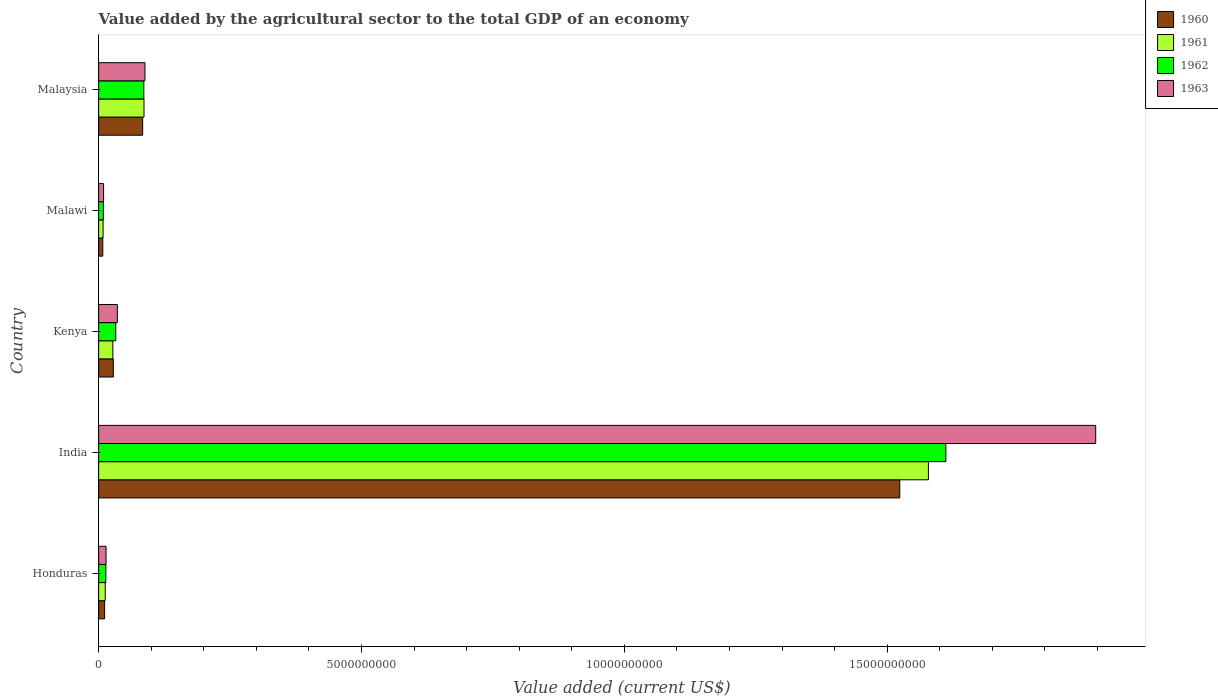How many different coloured bars are there?
Give a very brief answer. 4. How many groups of bars are there?
Your response must be concise. 5. Are the number of bars per tick equal to the number of legend labels?
Offer a terse response. Yes. Are the number of bars on each tick of the Y-axis equal?
Keep it short and to the point. Yes. How many bars are there on the 5th tick from the bottom?
Provide a short and direct response. 4. What is the label of the 4th group of bars from the top?
Your answer should be very brief. India. In how many cases, is the number of bars for a given country not equal to the number of legend labels?
Ensure brevity in your answer.  0. What is the value added by the agricultural sector to the total GDP in 1961 in Malaysia?
Your response must be concise. 8.63e+08. Across all countries, what is the maximum value added by the agricultural sector to the total GDP in 1962?
Your answer should be very brief. 1.61e+1. Across all countries, what is the minimum value added by the agricultural sector to the total GDP in 1960?
Keep it short and to the point. 7.88e+07. In which country was the value added by the agricultural sector to the total GDP in 1963 maximum?
Make the answer very short. India. In which country was the value added by the agricultural sector to the total GDP in 1960 minimum?
Make the answer very short. Malawi. What is the total value added by the agricultural sector to the total GDP in 1960 in the graph?
Give a very brief answer. 1.65e+1. What is the difference between the value added by the agricultural sector to the total GDP in 1961 in India and that in Malawi?
Provide a succinct answer. 1.57e+1. What is the difference between the value added by the agricultural sector to the total GDP in 1963 in Malaysia and the value added by the agricultural sector to the total GDP in 1960 in Honduras?
Ensure brevity in your answer.  7.68e+08. What is the average value added by the agricultural sector to the total GDP in 1960 per country?
Your response must be concise. 3.31e+09. What is the difference between the value added by the agricultural sector to the total GDP in 1963 and value added by the agricultural sector to the total GDP in 1960 in India?
Give a very brief answer. 3.73e+09. What is the ratio of the value added by the agricultural sector to the total GDP in 1961 in Kenya to that in Malaysia?
Provide a succinct answer. 0.31. What is the difference between the highest and the second highest value added by the agricultural sector to the total GDP in 1961?
Offer a very short reply. 1.49e+1. What is the difference between the highest and the lowest value added by the agricultural sector to the total GDP in 1963?
Provide a short and direct response. 1.89e+1. In how many countries, is the value added by the agricultural sector to the total GDP in 1962 greater than the average value added by the agricultural sector to the total GDP in 1962 taken over all countries?
Keep it short and to the point. 1. Is the sum of the value added by the agricultural sector to the total GDP in 1960 in India and Malaysia greater than the maximum value added by the agricultural sector to the total GDP in 1961 across all countries?
Make the answer very short. Yes. What does the 4th bar from the top in Malawi represents?
Provide a succinct answer. 1960. What does the 4th bar from the bottom in Kenya represents?
Provide a short and direct response. 1963. How many bars are there?
Offer a terse response. 20. Where does the legend appear in the graph?
Ensure brevity in your answer.  Top right. How many legend labels are there?
Offer a terse response. 4. How are the legend labels stacked?
Offer a very short reply. Vertical. What is the title of the graph?
Provide a short and direct response. Value added by the agricultural sector to the total GDP of an economy. Does "1974" appear as one of the legend labels in the graph?
Keep it short and to the point. No. What is the label or title of the X-axis?
Offer a terse response. Value added (current US$). What is the label or title of the Y-axis?
Make the answer very short. Country. What is the Value added (current US$) in 1960 in Honduras?
Your answer should be very brief. 1.14e+08. What is the Value added (current US$) of 1961 in Honduras?
Make the answer very short. 1.26e+08. What is the Value added (current US$) of 1962 in Honduras?
Your answer should be very brief. 1.37e+08. What is the Value added (current US$) of 1963 in Honduras?
Provide a short and direct response. 1.41e+08. What is the Value added (current US$) of 1960 in India?
Give a very brief answer. 1.52e+1. What is the Value added (current US$) in 1961 in India?
Offer a very short reply. 1.58e+1. What is the Value added (current US$) in 1962 in India?
Offer a very short reply. 1.61e+1. What is the Value added (current US$) in 1963 in India?
Ensure brevity in your answer.  1.90e+1. What is the Value added (current US$) in 1960 in Kenya?
Make the answer very short. 2.80e+08. What is the Value added (current US$) in 1961 in Kenya?
Ensure brevity in your answer.  2.70e+08. What is the Value added (current US$) of 1962 in Kenya?
Offer a very short reply. 3.26e+08. What is the Value added (current US$) in 1963 in Kenya?
Your response must be concise. 3.56e+08. What is the Value added (current US$) in 1960 in Malawi?
Offer a very short reply. 7.88e+07. What is the Value added (current US$) in 1961 in Malawi?
Your answer should be very brief. 8.48e+07. What is the Value added (current US$) in 1962 in Malawi?
Your answer should be very brief. 8.90e+07. What is the Value added (current US$) in 1963 in Malawi?
Provide a short and direct response. 9.39e+07. What is the Value added (current US$) in 1960 in Malaysia?
Provide a succinct answer. 8.38e+08. What is the Value added (current US$) of 1961 in Malaysia?
Your answer should be compact. 8.63e+08. What is the Value added (current US$) of 1962 in Malaysia?
Make the answer very short. 8.60e+08. What is the Value added (current US$) of 1963 in Malaysia?
Keep it short and to the point. 8.82e+08. Across all countries, what is the maximum Value added (current US$) in 1960?
Make the answer very short. 1.52e+1. Across all countries, what is the maximum Value added (current US$) in 1961?
Offer a terse response. 1.58e+1. Across all countries, what is the maximum Value added (current US$) in 1962?
Make the answer very short. 1.61e+1. Across all countries, what is the maximum Value added (current US$) of 1963?
Offer a terse response. 1.90e+1. Across all countries, what is the minimum Value added (current US$) of 1960?
Keep it short and to the point. 7.88e+07. Across all countries, what is the minimum Value added (current US$) of 1961?
Offer a terse response. 8.48e+07. Across all countries, what is the minimum Value added (current US$) of 1962?
Make the answer very short. 8.90e+07. Across all countries, what is the minimum Value added (current US$) of 1963?
Offer a very short reply. 9.39e+07. What is the total Value added (current US$) in 1960 in the graph?
Provide a short and direct response. 1.65e+1. What is the total Value added (current US$) in 1961 in the graph?
Your answer should be compact. 1.71e+1. What is the total Value added (current US$) of 1962 in the graph?
Offer a very short reply. 1.75e+1. What is the total Value added (current US$) in 1963 in the graph?
Your response must be concise. 2.04e+1. What is the difference between the Value added (current US$) in 1960 in Honduras and that in India?
Your response must be concise. -1.51e+1. What is the difference between the Value added (current US$) in 1961 in Honduras and that in India?
Offer a very short reply. -1.57e+1. What is the difference between the Value added (current US$) in 1962 in Honduras and that in India?
Provide a succinct answer. -1.60e+1. What is the difference between the Value added (current US$) of 1963 in Honduras and that in India?
Your answer should be very brief. -1.88e+1. What is the difference between the Value added (current US$) of 1960 in Honduras and that in Kenya?
Ensure brevity in your answer.  -1.66e+08. What is the difference between the Value added (current US$) of 1961 in Honduras and that in Kenya?
Provide a short and direct response. -1.45e+08. What is the difference between the Value added (current US$) of 1962 in Honduras and that in Kenya?
Provide a short and direct response. -1.89e+08. What is the difference between the Value added (current US$) in 1963 in Honduras and that in Kenya?
Your response must be concise. -2.15e+08. What is the difference between the Value added (current US$) in 1960 in Honduras and that in Malawi?
Ensure brevity in your answer.  3.47e+07. What is the difference between the Value added (current US$) of 1961 in Honduras and that in Malawi?
Offer a terse response. 4.08e+07. What is the difference between the Value added (current US$) of 1962 in Honduras and that in Malawi?
Keep it short and to the point. 4.82e+07. What is the difference between the Value added (current US$) in 1963 in Honduras and that in Malawi?
Offer a very short reply. 4.72e+07. What is the difference between the Value added (current US$) in 1960 in Honduras and that in Malaysia?
Provide a succinct answer. -7.24e+08. What is the difference between the Value added (current US$) in 1961 in Honduras and that in Malaysia?
Provide a succinct answer. -7.37e+08. What is the difference between the Value added (current US$) of 1962 in Honduras and that in Malaysia?
Make the answer very short. -7.23e+08. What is the difference between the Value added (current US$) of 1963 in Honduras and that in Malaysia?
Give a very brief answer. -7.40e+08. What is the difference between the Value added (current US$) of 1960 in India and that in Kenya?
Offer a very short reply. 1.50e+1. What is the difference between the Value added (current US$) in 1961 in India and that in Kenya?
Offer a terse response. 1.55e+1. What is the difference between the Value added (current US$) of 1962 in India and that in Kenya?
Keep it short and to the point. 1.58e+1. What is the difference between the Value added (current US$) in 1963 in India and that in Kenya?
Your response must be concise. 1.86e+1. What is the difference between the Value added (current US$) of 1960 in India and that in Malawi?
Offer a very short reply. 1.52e+1. What is the difference between the Value added (current US$) in 1961 in India and that in Malawi?
Your response must be concise. 1.57e+1. What is the difference between the Value added (current US$) in 1962 in India and that in Malawi?
Your response must be concise. 1.60e+1. What is the difference between the Value added (current US$) in 1963 in India and that in Malawi?
Your answer should be very brief. 1.89e+1. What is the difference between the Value added (current US$) of 1960 in India and that in Malaysia?
Keep it short and to the point. 1.44e+1. What is the difference between the Value added (current US$) in 1961 in India and that in Malaysia?
Make the answer very short. 1.49e+1. What is the difference between the Value added (current US$) in 1962 in India and that in Malaysia?
Make the answer very short. 1.53e+1. What is the difference between the Value added (current US$) in 1963 in India and that in Malaysia?
Your answer should be very brief. 1.81e+1. What is the difference between the Value added (current US$) in 1960 in Kenya and that in Malawi?
Your response must be concise. 2.01e+08. What is the difference between the Value added (current US$) of 1961 in Kenya and that in Malawi?
Ensure brevity in your answer.  1.85e+08. What is the difference between the Value added (current US$) in 1962 in Kenya and that in Malawi?
Offer a very short reply. 2.37e+08. What is the difference between the Value added (current US$) of 1963 in Kenya and that in Malawi?
Offer a very short reply. 2.62e+08. What is the difference between the Value added (current US$) of 1960 in Kenya and that in Malaysia?
Your response must be concise. -5.58e+08. What is the difference between the Value added (current US$) of 1961 in Kenya and that in Malaysia?
Provide a short and direct response. -5.93e+08. What is the difference between the Value added (current US$) of 1962 in Kenya and that in Malaysia?
Offer a very short reply. -5.34e+08. What is the difference between the Value added (current US$) of 1963 in Kenya and that in Malaysia?
Your answer should be very brief. -5.25e+08. What is the difference between the Value added (current US$) of 1960 in Malawi and that in Malaysia?
Offer a terse response. -7.59e+08. What is the difference between the Value added (current US$) of 1961 in Malawi and that in Malaysia?
Make the answer very short. -7.78e+08. What is the difference between the Value added (current US$) in 1962 in Malawi and that in Malaysia?
Your answer should be very brief. -7.71e+08. What is the difference between the Value added (current US$) of 1963 in Malawi and that in Malaysia?
Offer a very short reply. -7.88e+08. What is the difference between the Value added (current US$) in 1960 in Honduras and the Value added (current US$) in 1961 in India?
Your response must be concise. -1.57e+1. What is the difference between the Value added (current US$) of 1960 in Honduras and the Value added (current US$) of 1962 in India?
Your answer should be compact. -1.60e+1. What is the difference between the Value added (current US$) of 1960 in Honduras and the Value added (current US$) of 1963 in India?
Offer a very short reply. -1.89e+1. What is the difference between the Value added (current US$) of 1961 in Honduras and the Value added (current US$) of 1962 in India?
Offer a terse response. -1.60e+1. What is the difference between the Value added (current US$) of 1961 in Honduras and the Value added (current US$) of 1963 in India?
Your answer should be very brief. -1.88e+1. What is the difference between the Value added (current US$) of 1962 in Honduras and the Value added (current US$) of 1963 in India?
Keep it short and to the point. -1.88e+1. What is the difference between the Value added (current US$) of 1960 in Honduras and the Value added (current US$) of 1961 in Kenya?
Offer a terse response. -1.57e+08. What is the difference between the Value added (current US$) of 1960 in Honduras and the Value added (current US$) of 1962 in Kenya?
Your answer should be compact. -2.13e+08. What is the difference between the Value added (current US$) in 1960 in Honduras and the Value added (current US$) in 1963 in Kenya?
Make the answer very short. -2.43e+08. What is the difference between the Value added (current US$) of 1961 in Honduras and the Value added (current US$) of 1962 in Kenya?
Make the answer very short. -2.01e+08. What is the difference between the Value added (current US$) in 1961 in Honduras and the Value added (current US$) in 1963 in Kenya?
Make the answer very short. -2.31e+08. What is the difference between the Value added (current US$) in 1962 in Honduras and the Value added (current US$) in 1963 in Kenya?
Provide a succinct answer. -2.19e+08. What is the difference between the Value added (current US$) in 1960 in Honduras and the Value added (current US$) in 1961 in Malawi?
Offer a terse response. 2.87e+07. What is the difference between the Value added (current US$) of 1960 in Honduras and the Value added (current US$) of 1962 in Malawi?
Your response must be concise. 2.45e+07. What is the difference between the Value added (current US$) in 1960 in Honduras and the Value added (current US$) in 1963 in Malawi?
Provide a short and direct response. 1.96e+07. What is the difference between the Value added (current US$) of 1961 in Honduras and the Value added (current US$) of 1962 in Malawi?
Provide a succinct answer. 3.66e+07. What is the difference between the Value added (current US$) in 1961 in Honduras and the Value added (current US$) in 1963 in Malawi?
Ensure brevity in your answer.  3.17e+07. What is the difference between the Value added (current US$) of 1962 in Honduras and the Value added (current US$) of 1963 in Malawi?
Offer a very short reply. 4.33e+07. What is the difference between the Value added (current US$) in 1960 in Honduras and the Value added (current US$) in 1961 in Malaysia?
Ensure brevity in your answer.  -7.50e+08. What is the difference between the Value added (current US$) in 1960 in Honduras and the Value added (current US$) in 1962 in Malaysia?
Offer a terse response. -7.47e+08. What is the difference between the Value added (current US$) of 1960 in Honduras and the Value added (current US$) of 1963 in Malaysia?
Your answer should be compact. -7.68e+08. What is the difference between the Value added (current US$) of 1961 in Honduras and the Value added (current US$) of 1962 in Malaysia?
Offer a terse response. -7.34e+08. What is the difference between the Value added (current US$) in 1961 in Honduras and the Value added (current US$) in 1963 in Malaysia?
Keep it short and to the point. -7.56e+08. What is the difference between the Value added (current US$) in 1962 in Honduras and the Value added (current US$) in 1963 in Malaysia?
Your response must be concise. -7.44e+08. What is the difference between the Value added (current US$) of 1960 in India and the Value added (current US$) of 1961 in Kenya?
Provide a succinct answer. 1.50e+1. What is the difference between the Value added (current US$) in 1960 in India and the Value added (current US$) in 1962 in Kenya?
Your answer should be compact. 1.49e+1. What is the difference between the Value added (current US$) in 1960 in India and the Value added (current US$) in 1963 in Kenya?
Your answer should be very brief. 1.49e+1. What is the difference between the Value added (current US$) in 1961 in India and the Value added (current US$) in 1962 in Kenya?
Make the answer very short. 1.55e+1. What is the difference between the Value added (current US$) in 1961 in India and the Value added (current US$) in 1963 in Kenya?
Your answer should be very brief. 1.54e+1. What is the difference between the Value added (current US$) of 1962 in India and the Value added (current US$) of 1963 in Kenya?
Offer a terse response. 1.58e+1. What is the difference between the Value added (current US$) in 1960 in India and the Value added (current US$) in 1961 in Malawi?
Your response must be concise. 1.52e+1. What is the difference between the Value added (current US$) of 1960 in India and the Value added (current US$) of 1962 in Malawi?
Give a very brief answer. 1.51e+1. What is the difference between the Value added (current US$) in 1960 in India and the Value added (current US$) in 1963 in Malawi?
Offer a terse response. 1.51e+1. What is the difference between the Value added (current US$) of 1961 in India and the Value added (current US$) of 1962 in Malawi?
Your answer should be very brief. 1.57e+1. What is the difference between the Value added (current US$) in 1961 in India and the Value added (current US$) in 1963 in Malawi?
Your answer should be compact. 1.57e+1. What is the difference between the Value added (current US$) in 1962 in India and the Value added (current US$) in 1963 in Malawi?
Your response must be concise. 1.60e+1. What is the difference between the Value added (current US$) of 1960 in India and the Value added (current US$) of 1961 in Malaysia?
Your response must be concise. 1.44e+1. What is the difference between the Value added (current US$) of 1960 in India and the Value added (current US$) of 1962 in Malaysia?
Make the answer very short. 1.44e+1. What is the difference between the Value added (current US$) in 1960 in India and the Value added (current US$) in 1963 in Malaysia?
Offer a very short reply. 1.44e+1. What is the difference between the Value added (current US$) of 1961 in India and the Value added (current US$) of 1962 in Malaysia?
Ensure brevity in your answer.  1.49e+1. What is the difference between the Value added (current US$) of 1961 in India and the Value added (current US$) of 1963 in Malaysia?
Provide a succinct answer. 1.49e+1. What is the difference between the Value added (current US$) in 1962 in India and the Value added (current US$) in 1963 in Malaysia?
Your answer should be very brief. 1.52e+1. What is the difference between the Value added (current US$) in 1960 in Kenya and the Value added (current US$) in 1961 in Malawi?
Keep it short and to the point. 1.95e+08. What is the difference between the Value added (current US$) of 1960 in Kenya and the Value added (current US$) of 1962 in Malawi?
Your answer should be very brief. 1.91e+08. What is the difference between the Value added (current US$) in 1960 in Kenya and the Value added (current US$) in 1963 in Malawi?
Your answer should be compact. 1.86e+08. What is the difference between the Value added (current US$) in 1961 in Kenya and the Value added (current US$) in 1962 in Malawi?
Offer a very short reply. 1.81e+08. What is the difference between the Value added (current US$) of 1961 in Kenya and the Value added (current US$) of 1963 in Malawi?
Provide a short and direct response. 1.76e+08. What is the difference between the Value added (current US$) in 1962 in Kenya and the Value added (current US$) in 1963 in Malawi?
Give a very brief answer. 2.32e+08. What is the difference between the Value added (current US$) in 1960 in Kenya and the Value added (current US$) in 1961 in Malaysia?
Offer a terse response. -5.83e+08. What is the difference between the Value added (current US$) in 1960 in Kenya and the Value added (current US$) in 1962 in Malaysia?
Make the answer very short. -5.80e+08. What is the difference between the Value added (current US$) of 1960 in Kenya and the Value added (current US$) of 1963 in Malaysia?
Offer a very short reply. -6.02e+08. What is the difference between the Value added (current US$) in 1961 in Kenya and the Value added (current US$) in 1962 in Malaysia?
Offer a terse response. -5.90e+08. What is the difference between the Value added (current US$) of 1961 in Kenya and the Value added (current US$) of 1963 in Malaysia?
Provide a short and direct response. -6.11e+08. What is the difference between the Value added (current US$) in 1962 in Kenya and the Value added (current US$) in 1963 in Malaysia?
Make the answer very short. -5.55e+08. What is the difference between the Value added (current US$) in 1960 in Malawi and the Value added (current US$) in 1961 in Malaysia?
Ensure brevity in your answer.  -7.84e+08. What is the difference between the Value added (current US$) of 1960 in Malawi and the Value added (current US$) of 1962 in Malaysia?
Give a very brief answer. -7.81e+08. What is the difference between the Value added (current US$) in 1960 in Malawi and the Value added (current US$) in 1963 in Malaysia?
Offer a very short reply. -8.03e+08. What is the difference between the Value added (current US$) of 1961 in Malawi and the Value added (current US$) of 1962 in Malaysia?
Your answer should be very brief. -7.75e+08. What is the difference between the Value added (current US$) of 1961 in Malawi and the Value added (current US$) of 1963 in Malaysia?
Your response must be concise. -7.97e+08. What is the difference between the Value added (current US$) in 1962 in Malawi and the Value added (current US$) in 1963 in Malaysia?
Make the answer very short. -7.93e+08. What is the average Value added (current US$) in 1960 per country?
Your answer should be very brief. 3.31e+09. What is the average Value added (current US$) of 1961 per country?
Offer a terse response. 3.43e+09. What is the average Value added (current US$) of 1962 per country?
Give a very brief answer. 3.51e+09. What is the average Value added (current US$) of 1963 per country?
Keep it short and to the point. 4.09e+09. What is the difference between the Value added (current US$) of 1960 and Value added (current US$) of 1961 in Honduras?
Your answer should be very brief. -1.21e+07. What is the difference between the Value added (current US$) of 1960 and Value added (current US$) of 1962 in Honduras?
Offer a very short reply. -2.38e+07. What is the difference between the Value added (current US$) in 1960 and Value added (current US$) in 1963 in Honduras?
Ensure brevity in your answer.  -2.76e+07. What is the difference between the Value added (current US$) in 1961 and Value added (current US$) in 1962 in Honduras?
Give a very brief answer. -1.16e+07. What is the difference between the Value added (current US$) in 1961 and Value added (current US$) in 1963 in Honduras?
Provide a succinct answer. -1.56e+07. What is the difference between the Value added (current US$) in 1962 and Value added (current US$) in 1963 in Honduras?
Ensure brevity in your answer.  -3.90e+06. What is the difference between the Value added (current US$) in 1960 and Value added (current US$) in 1961 in India?
Your response must be concise. -5.45e+08. What is the difference between the Value added (current US$) of 1960 and Value added (current US$) of 1962 in India?
Provide a succinct answer. -8.76e+08. What is the difference between the Value added (current US$) of 1960 and Value added (current US$) of 1963 in India?
Offer a terse response. -3.73e+09. What is the difference between the Value added (current US$) in 1961 and Value added (current US$) in 1962 in India?
Give a very brief answer. -3.32e+08. What is the difference between the Value added (current US$) of 1961 and Value added (current US$) of 1963 in India?
Give a very brief answer. -3.18e+09. What is the difference between the Value added (current US$) of 1962 and Value added (current US$) of 1963 in India?
Your response must be concise. -2.85e+09. What is the difference between the Value added (current US$) in 1960 and Value added (current US$) in 1961 in Kenya?
Your response must be concise. 9.51e+06. What is the difference between the Value added (current US$) of 1960 and Value added (current US$) of 1962 in Kenya?
Give a very brief answer. -4.65e+07. What is the difference between the Value added (current US$) of 1960 and Value added (current US$) of 1963 in Kenya?
Make the answer very short. -7.66e+07. What is the difference between the Value added (current US$) in 1961 and Value added (current US$) in 1962 in Kenya?
Your response must be concise. -5.60e+07. What is the difference between the Value added (current US$) in 1961 and Value added (current US$) in 1963 in Kenya?
Keep it short and to the point. -8.61e+07. What is the difference between the Value added (current US$) in 1962 and Value added (current US$) in 1963 in Kenya?
Provide a short and direct response. -3.01e+07. What is the difference between the Value added (current US$) of 1960 and Value added (current US$) of 1961 in Malawi?
Give a very brief answer. -6.02e+06. What is the difference between the Value added (current US$) in 1960 and Value added (current US$) in 1962 in Malawi?
Your answer should be very brief. -1.02e+07. What is the difference between the Value added (current US$) of 1960 and Value added (current US$) of 1963 in Malawi?
Give a very brief answer. -1.51e+07. What is the difference between the Value added (current US$) in 1961 and Value added (current US$) in 1962 in Malawi?
Offer a very short reply. -4.20e+06. What is the difference between the Value added (current US$) of 1961 and Value added (current US$) of 1963 in Malawi?
Your answer should be compact. -9.10e+06. What is the difference between the Value added (current US$) of 1962 and Value added (current US$) of 1963 in Malawi?
Provide a succinct answer. -4.90e+06. What is the difference between the Value added (current US$) of 1960 and Value added (current US$) of 1961 in Malaysia?
Provide a succinct answer. -2.54e+07. What is the difference between the Value added (current US$) in 1960 and Value added (current US$) in 1962 in Malaysia?
Your response must be concise. -2.23e+07. What is the difference between the Value added (current US$) in 1960 and Value added (current US$) in 1963 in Malaysia?
Provide a succinct answer. -4.39e+07. What is the difference between the Value added (current US$) in 1961 and Value added (current US$) in 1962 in Malaysia?
Make the answer very short. 3.09e+06. What is the difference between the Value added (current US$) in 1961 and Value added (current US$) in 1963 in Malaysia?
Your response must be concise. -1.85e+07. What is the difference between the Value added (current US$) in 1962 and Value added (current US$) in 1963 in Malaysia?
Your answer should be very brief. -2.16e+07. What is the ratio of the Value added (current US$) in 1960 in Honduras to that in India?
Your response must be concise. 0.01. What is the ratio of the Value added (current US$) of 1961 in Honduras to that in India?
Offer a terse response. 0.01. What is the ratio of the Value added (current US$) of 1962 in Honduras to that in India?
Make the answer very short. 0.01. What is the ratio of the Value added (current US$) of 1963 in Honduras to that in India?
Your answer should be compact. 0.01. What is the ratio of the Value added (current US$) of 1960 in Honduras to that in Kenya?
Keep it short and to the point. 0.41. What is the ratio of the Value added (current US$) in 1961 in Honduras to that in Kenya?
Make the answer very short. 0.46. What is the ratio of the Value added (current US$) in 1962 in Honduras to that in Kenya?
Provide a short and direct response. 0.42. What is the ratio of the Value added (current US$) of 1963 in Honduras to that in Kenya?
Provide a succinct answer. 0.4. What is the ratio of the Value added (current US$) of 1960 in Honduras to that in Malawi?
Make the answer very short. 1.44. What is the ratio of the Value added (current US$) in 1961 in Honduras to that in Malawi?
Ensure brevity in your answer.  1.48. What is the ratio of the Value added (current US$) of 1962 in Honduras to that in Malawi?
Make the answer very short. 1.54. What is the ratio of the Value added (current US$) of 1963 in Honduras to that in Malawi?
Your response must be concise. 1.5. What is the ratio of the Value added (current US$) in 1960 in Honduras to that in Malaysia?
Make the answer very short. 0.14. What is the ratio of the Value added (current US$) of 1961 in Honduras to that in Malaysia?
Provide a succinct answer. 0.15. What is the ratio of the Value added (current US$) in 1962 in Honduras to that in Malaysia?
Your answer should be very brief. 0.16. What is the ratio of the Value added (current US$) of 1963 in Honduras to that in Malaysia?
Keep it short and to the point. 0.16. What is the ratio of the Value added (current US$) of 1960 in India to that in Kenya?
Offer a terse response. 54.48. What is the ratio of the Value added (current US$) of 1961 in India to that in Kenya?
Your answer should be compact. 58.42. What is the ratio of the Value added (current US$) in 1962 in India to that in Kenya?
Ensure brevity in your answer.  49.4. What is the ratio of the Value added (current US$) of 1963 in India to that in Kenya?
Ensure brevity in your answer.  53.23. What is the ratio of the Value added (current US$) in 1960 in India to that in Malawi?
Your response must be concise. 193.33. What is the ratio of the Value added (current US$) of 1961 in India to that in Malawi?
Offer a terse response. 186.04. What is the ratio of the Value added (current US$) in 1962 in India to that in Malawi?
Offer a very short reply. 180.99. What is the ratio of the Value added (current US$) of 1963 in India to that in Malawi?
Provide a succinct answer. 201.89. What is the ratio of the Value added (current US$) of 1960 in India to that in Malaysia?
Offer a very short reply. 18.19. What is the ratio of the Value added (current US$) in 1961 in India to that in Malaysia?
Give a very brief answer. 18.29. What is the ratio of the Value added (current US$) in 1962 in India to that in Malaysia?
Provide a short and direct response. 18.74. What is the ratio of the Value added (current US$) of 1963 in India to that in Malaysia?
Offer a very short reply. 21.51. What is the ratio of the Value added (current US$) of 1960 in Kenya to that in Malawi?
Make the answer very short. 3.55. What is the ratio of the Value added (current US$) of 1961 in Kenya to that in Malawi?
Provide a short and direct response. 3.18. What is the ratio of the Value added (current US$) of 1962 in Kenya to that in Malawi?
Your answer should be very brief. 3.66. What is the ratio of the Value added (current US$) in 1963 in Kenya to that in Malawi?
Your answer should be compact. 3.79. What is the ratio of the Value added (current US$) of 1960 in Kenya to that in Malaysia?
Make the answer very short. 0.33. What is the ratio of the Value added (current US$) of 1961 in Kenya to that in Malaysia?
Your answer should be very brief. 0.31. What is the ratio of the Value added (current US$) in 1962 in Kenya to that in Malaysia?
Your answer should be very brief. 0.38. What is the ratio of the Value added (current US$) of 1963 in Kenya to that in Malaysia?
Your answer should be very brief. 0.4. What is the ratio of the Value added (current US$) in 1960 in Malawi to that in Malaysia?
Your answer should be very brief. 0.09. What is the ratio of the Value added (current US$) of 1961 in Malawi to that in Malaysia?
Your answer should be compact. 0.1. What is the ratio of the Value added (current US$) in 1962 in Malawi to that in Malaysia?
Keep it short and to the point. 0.1. What is the ratio of the Value added (current US$) in 1963 in Malawi to that in Malaysia?
Offer a very short reply. 0.11. What is the difference between the highest and the second highest Value added (current US$) of 1960?
Keep it short and to the point. 1.44e+1. What is the difference between the highest and the second highest Value added (current US$) in 1961?
Offer a very short reply. 1.49e+1. What is the difference between the highest and the second highest Value added (current US$) in 1962?
Offer a terse response. 1.53e+1. What is the difference between the highest and the second highest Value added (current US$) in 1963?
Give a very brief answer. 1.81e+1. What is the difference between the highest and the lowest Value added (current US$) in 1960?
Ensure brevity in your answer.  1.52e+1. What is the difference between the highest and the lowest Value added (current US$) of 1961?
Offer a very short reply. 1.57e+1. What is the difference between the highest and the lowest Value added (current US$) in 1962?
Ensure brevity in your answer.  1.60e+1. What is the difference between the highest and the lowest Value added (current US$) in 1963?
Ensure brevity in your answer.  1.89e+1. 